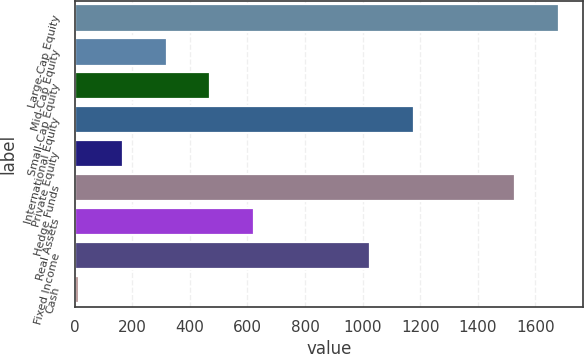Convert chart to OTSL. <chart><loc_0><loc_0><loc_500><loc_500><bar_chart><fcel>Large-Cap Equity<fcel>Mid-Cap Equity<fcel>Small-Cap Equity<fcel>International Equity<fcel>Private Equity<fcel>Hedge Funds<fcel>Real Assets<fcel>Fixed Income<fcel>Cash<nl><fcel>1682<fcel>319<fcel>471<fcel>1177<fcel>167<fcel>1530<fcel>623<fcel>1025<fcel>15<nl></chart> 